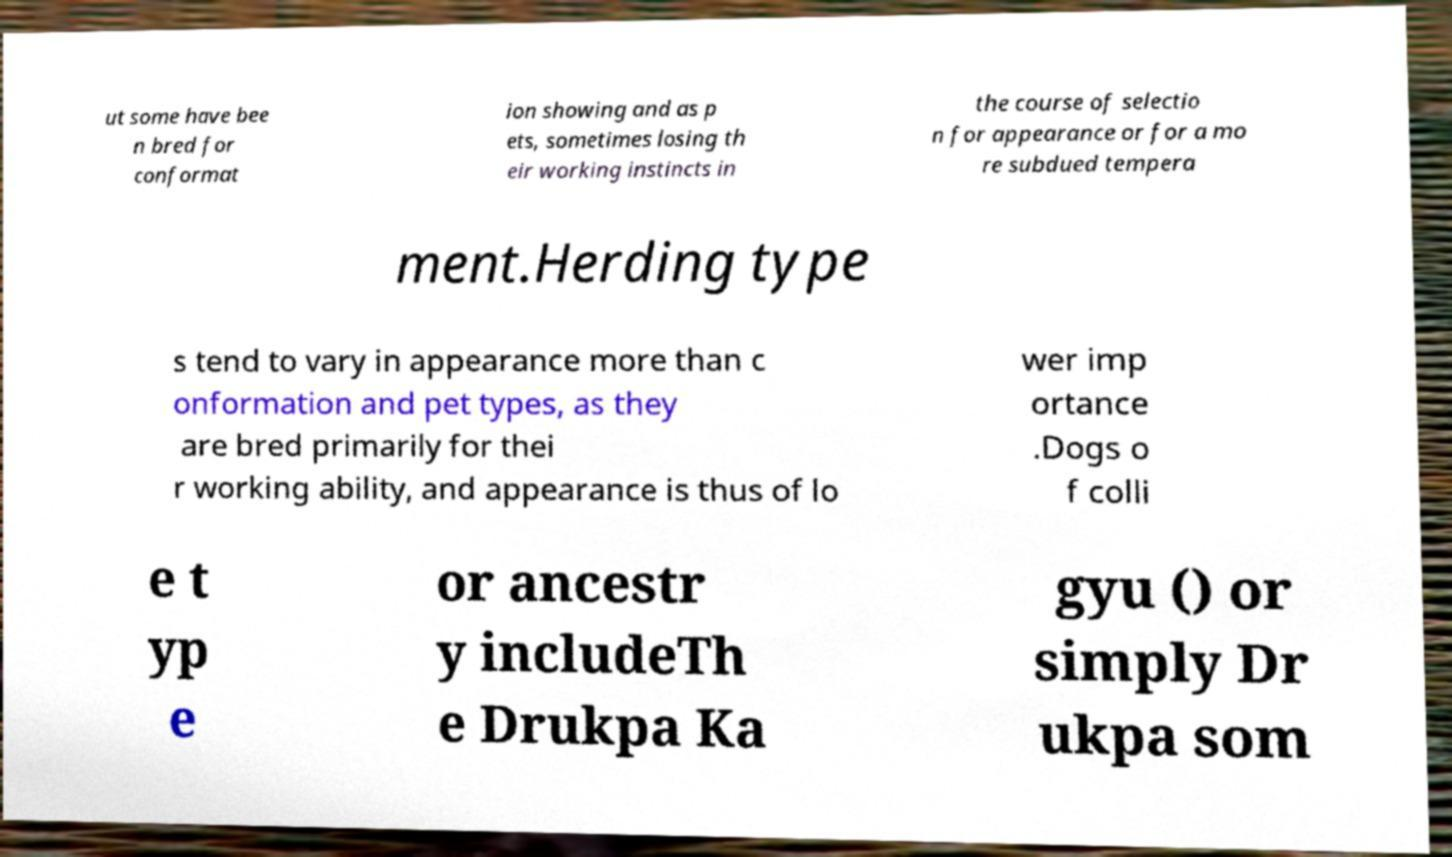There's text embedded in this image that I need extracted. Can you transcribe it verbatim? ut some have bee n bred for conformat ion showing and as p ets, sometimes losing th eir working instincts in the course of selectio n for appearance or for a mo re subdued tempera ment.Herding type s tend to vary in appearance more than c onformation and pet types, as they are bred primarily for thei r working ability, and appearance is thus of lo wer imp ortance .Dogs o f colli e t yp e or ancestr y includeTh e Drukpa Ka gyu () or simply Dr ukpa som 